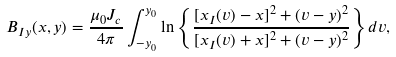Convert formula to latex. <formula><loc_0><loc_0><loc_500><loc_500>B _ { I y } ( x , y ) = \frac { \mu _ { 0 } J _ { c } } { 4 \pi } \int _ { - y _ { 0 } } ^ { y _ { 0 } } \ln \left \{ \frac { [ x _ { I } ( v ) - x ] ^ { 2 } + ( v - y ) ^ { 2 } } { [ x _ { I } ( v ) + x ] ^ { 2 } + ( v - y ) ^ { 2 } } \right \} d v ,</formula> 